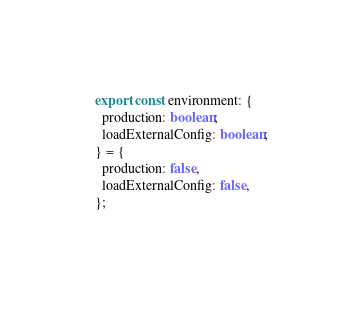<code> <loc_0><loc_0><loc_500><loc_500><_TypeScript_>export const environment: {
  production: boolean;
  loadExternalConfig: boolean;
} = {
  production: false,
  loadExternalConfig: false,
};
</code> 